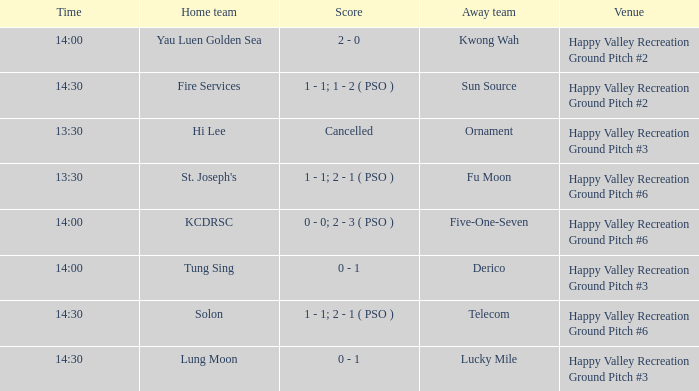What is the away team when solon was the home team? Telecom. 